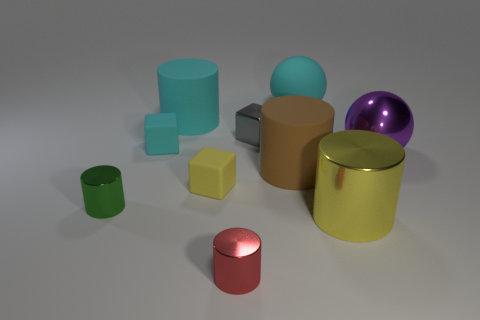Subtract all brown cylinders. Subtract all cyan spheres. How many cylinders are left? 4 Subtract all cubes. How many objects are left? 7 Add 3 large purple spheres. How many large purple spheres are left? 4 Add 10 tiny yellow metal things. How many tiny yellow metal things exist? 10 Subtract 1 purple spheres. How many objects are left? 9 Subtract all small cyan things. Subtract all large purple metallic balls. How many objects are left? 8 